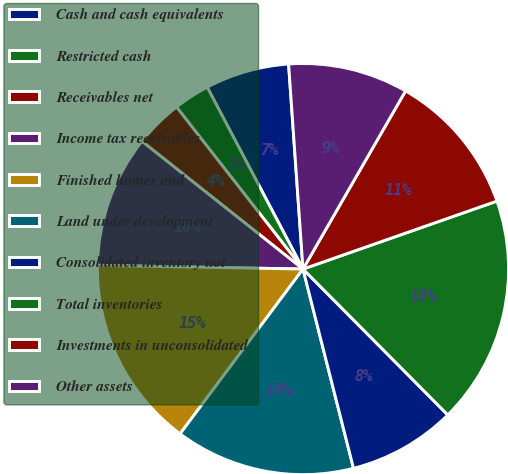Convert chart to OTSL. <chart><loc_0><loc_0><loc_500><loc_500><pie_chart><fcel>Cash and cash equivalents<fcel>Restricted cash<fcel>Receivables net<fcel>Income tax receivables<fcel>Finished homes and<fcel>Land under development<fcel>Consolidated inventory not<fcel>Total inventories<fcel>Investments in unconsolidated<fcel>Other assets<nl><fcel>6.6%<fcel>2.83%<fcel>3.78%<fcel>10.38%<fcel>15.09%<fcel>14.15%<fcel>8.49%<fcel>17.92%<fcel>11.32%<fcel>9.43%<nl></chart> 